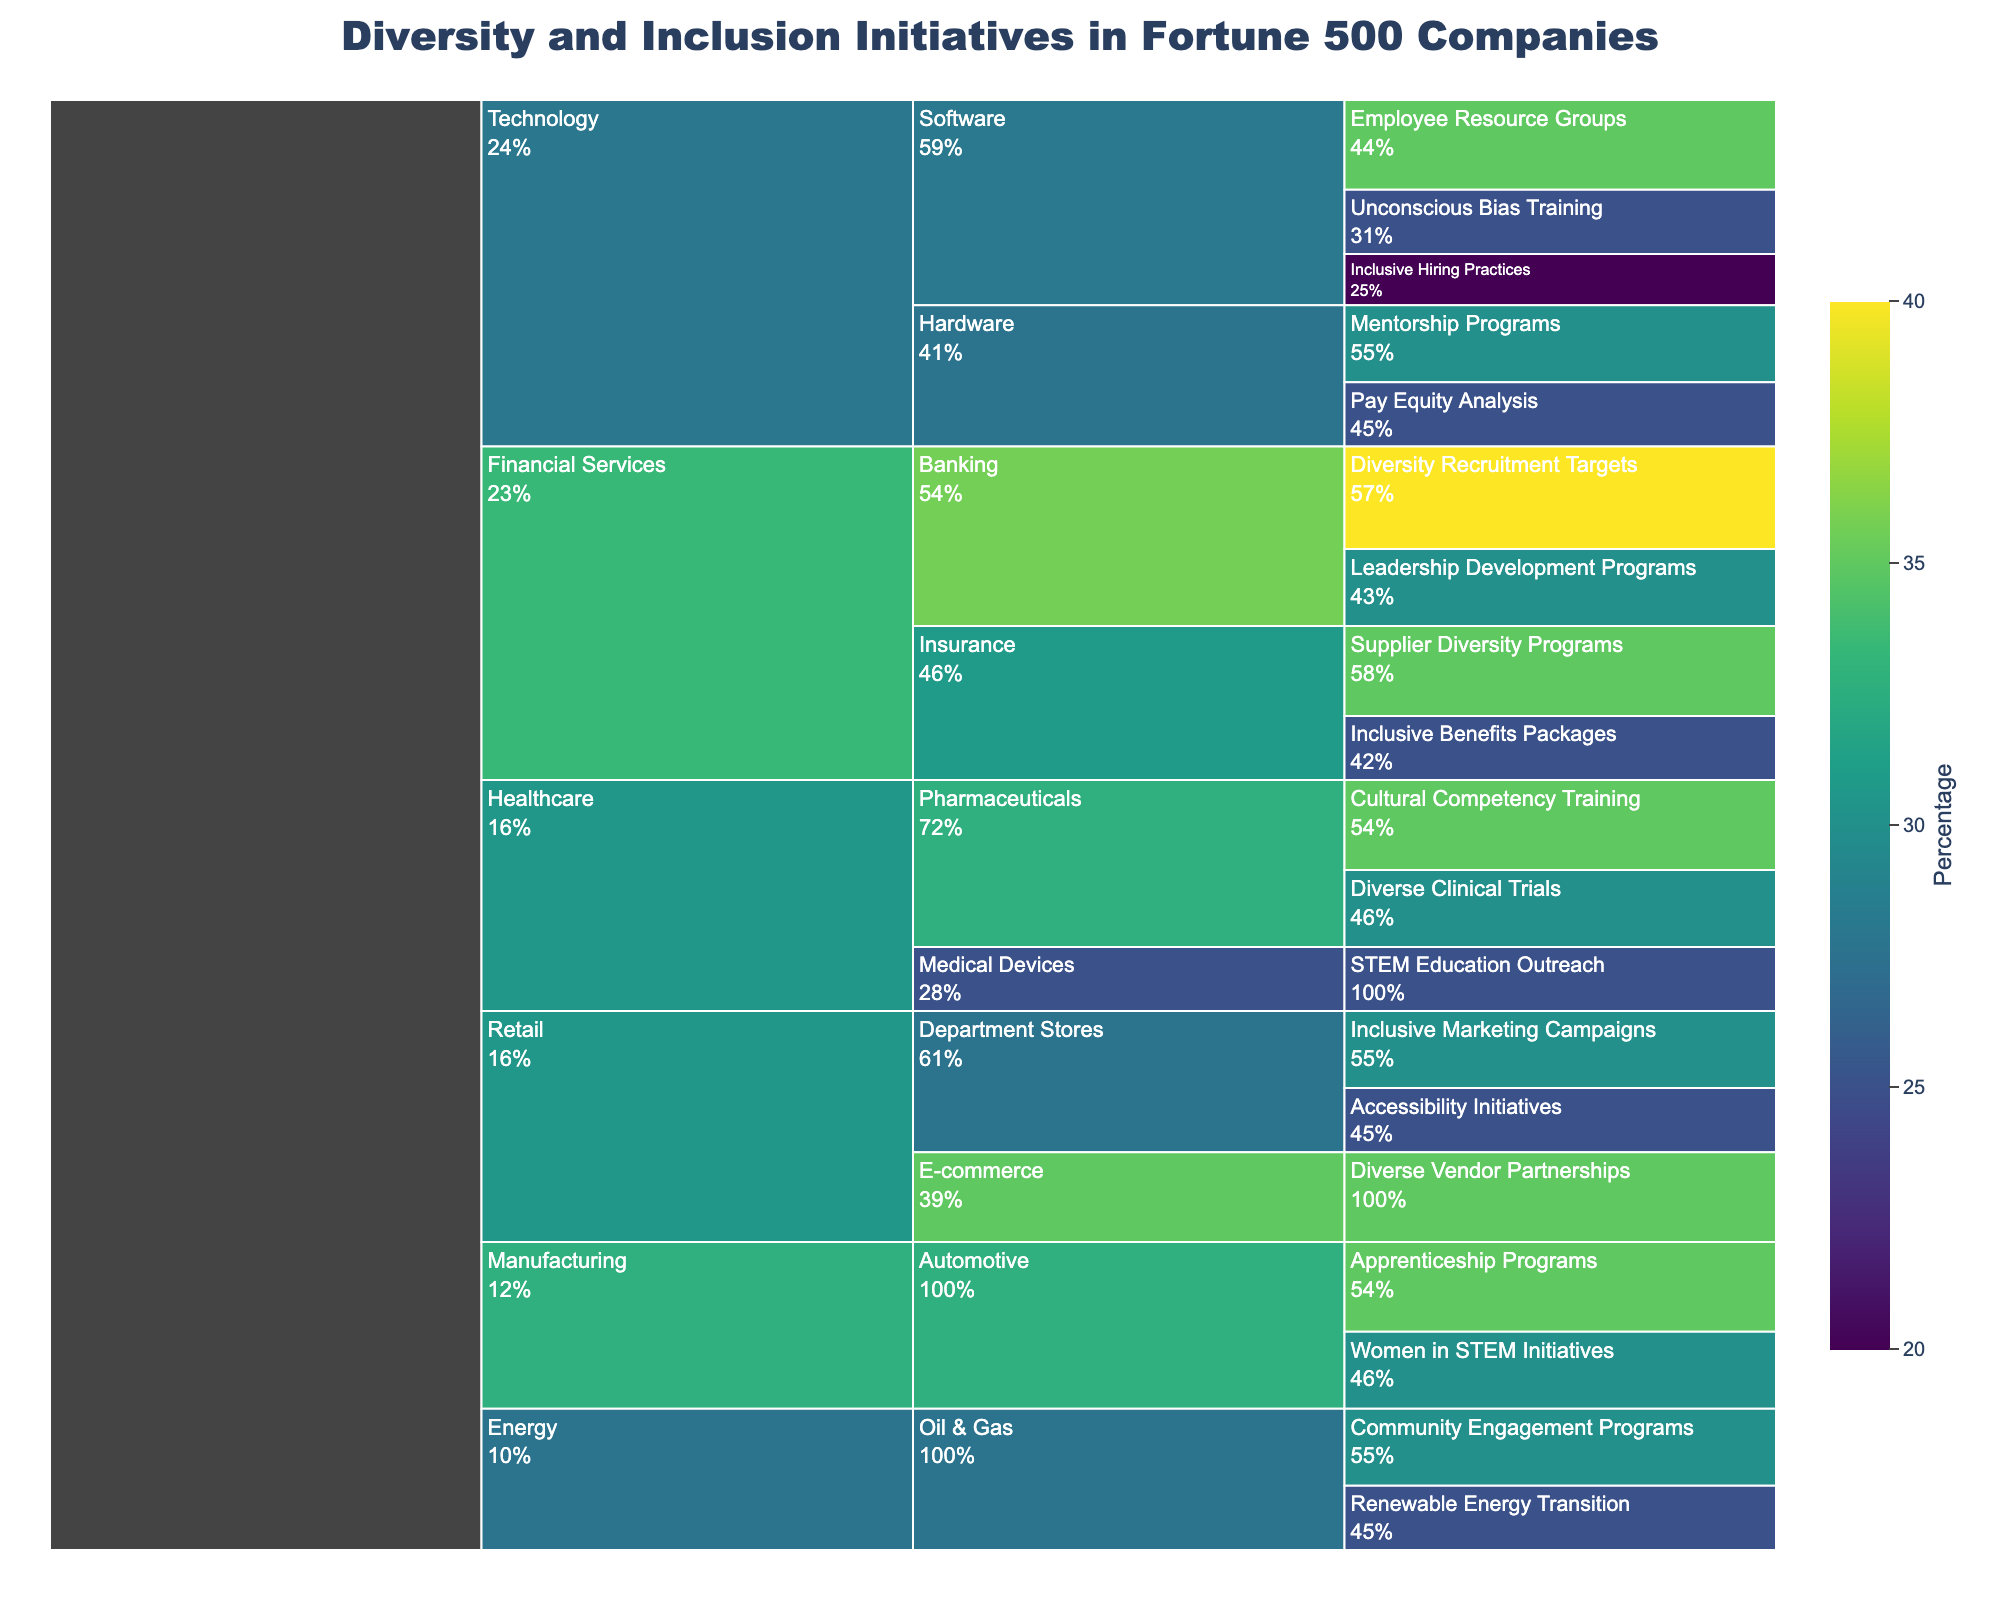What's the title of the chart? The title is located at the top of the icicle chart and directly indicates the main subject of the figure.
Answer: Diversity and Inclusion Initiatives in Fortune 500 Companies Which initiative under the "Healthcare" industry has the highest percentage? By examining the branches under the "Healthcare" industry in the icicle chart, we can see the percentages. The "Cultural Competency Training" under "Pharmaceuticals" has the highest percentage.
Answer: Cultural Competency Training What percentage of diversity initiatives in the "Retail" sector focuses on "Accessibility Initiatives"? Locate the "Retail" industry, then find the "Department Stores" sector. The branch for "Accessibility Initiatives" shows the percentage.
Answer: 25% What is the total percentage of diversity initiatives for the "Automotive" sector? Sum up the percentages of all initiatives under the "Automotive" sector in the icicle chart. "Apprenticeship Programs" (35%) + "Women in STEM Initiatives" (30%) = 65%
Answer: 65% Which has more diversity initiatives by percentage: "Software" or "Hardware" sector within "Technology"? Compare the sum of percentages of initiatives under "Software" (35% + 25% + 20% = 80%) with those under "Hardware" (30% + 25% = 55%).
Answer: Software What is the smallest percentage of an initiative under the "Financial Services" industry? Look at the different segments under the "Financial Services" industry and identify the smallest percentage. The "Inclusive Benefits Packages" under "Insurance" has the smallest percentage.
Answer: 25% How does the percentage of "Employee Resource Groups" in "Software" compare to "Community Engagement Programs" in "Oil & Gas"? Compare the percentage of "Employee Resource Groups" (35%) in "Software" with "Community Engagement Programs" (30%) in "Oil & Gas."
Answer: Employee Resource Groups are higher What is the sum of all diversity initiative percentages in the "Energy" industry? Add up the percentages of the initiatives under the "Energy" industry: "Community Engagement Programs" (30%) + "Renewable Energy Transition" (25%) = 55%
Answer: 55% How many unique industries are represented in the chart? Count the first-level branches of the icicle chart, with each branch representing a unique industry. There are "Technology," "Financial Services," "Healthcare," "Retail," "Energy," and "Manufacturing."
Answer: 6 What initiative in the "Technology" sector has the lowest percentage? Under the "Technology" industry, find the initiative with the lowest percentage comparing all initiatives. "Inclusive Hiring Practices" under "Software" has the lowest at 20%.
Answer: Inclusive Hiring Practices 